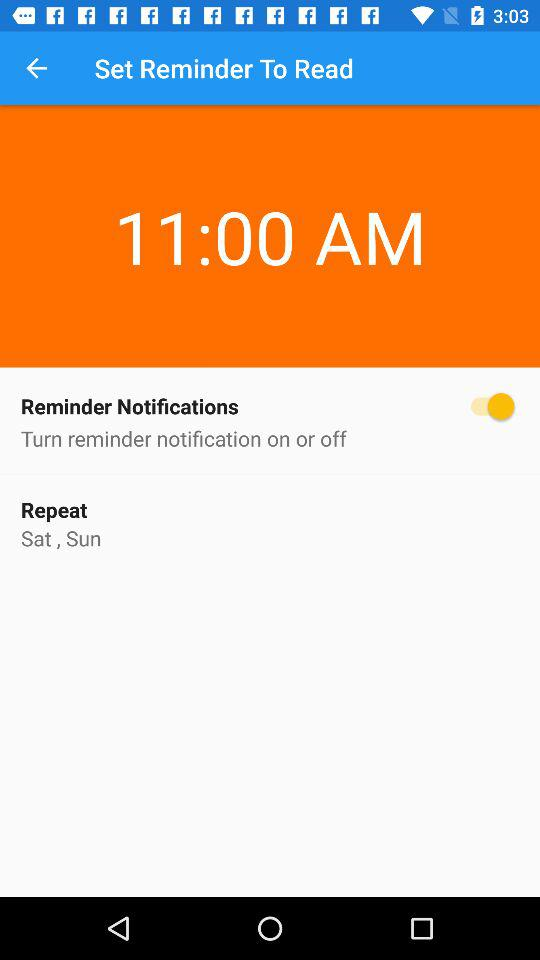What time is the reminder set for? The reminder is set for 11:00 a.m. 